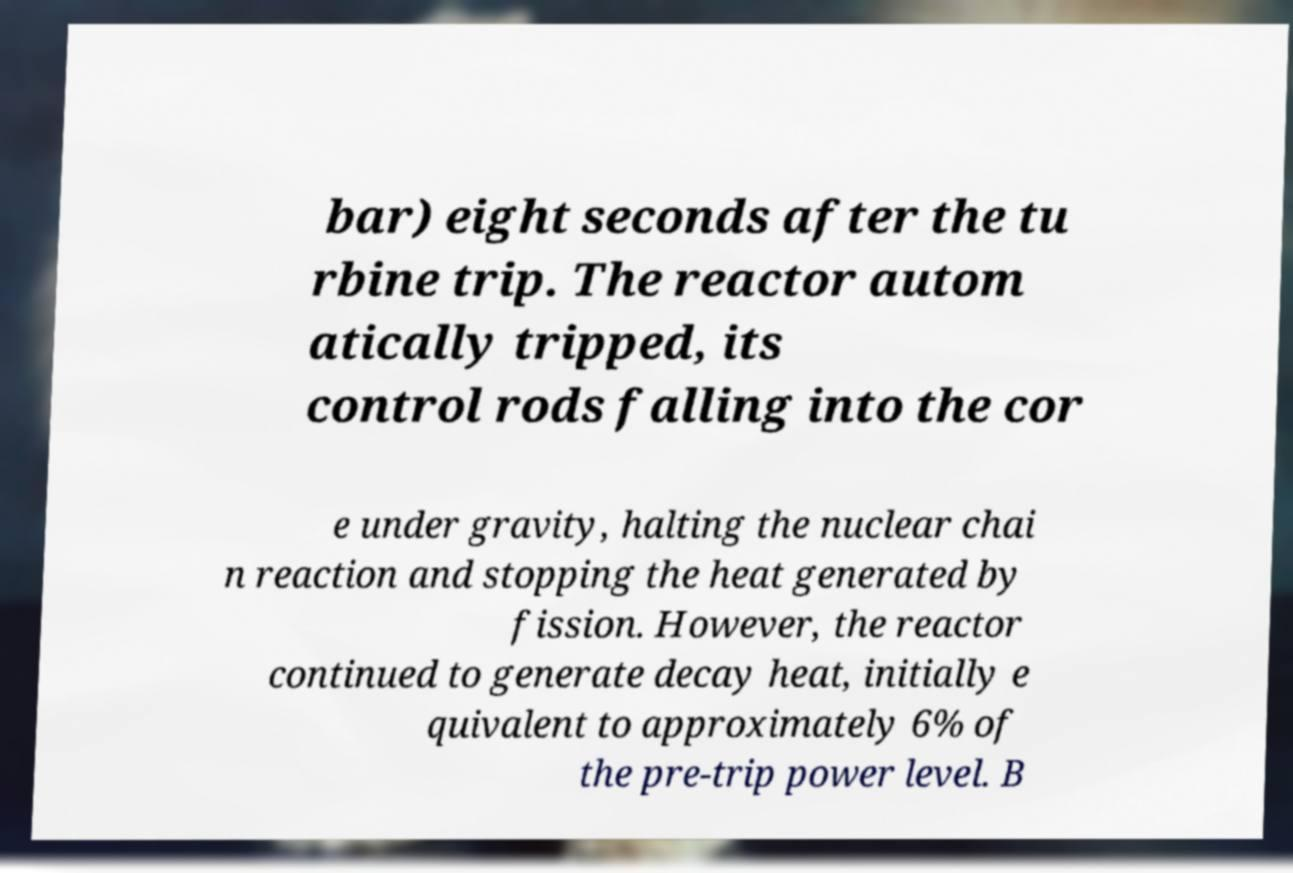Can you read and provide the text displayed in the image?This photo seems to have some interesting text. Can you extract and type it out for me? bar) eight seconds after the tu rbine trip. The reactor autom atically tripped, its control rods falling into the cor e under gravity, halting the nuclear chai n reaction and stopping the heat generated by fission. However, the reactor continued to generate decay heat, initially e quivalent to approximately 6% of the pre-trip power level. B 